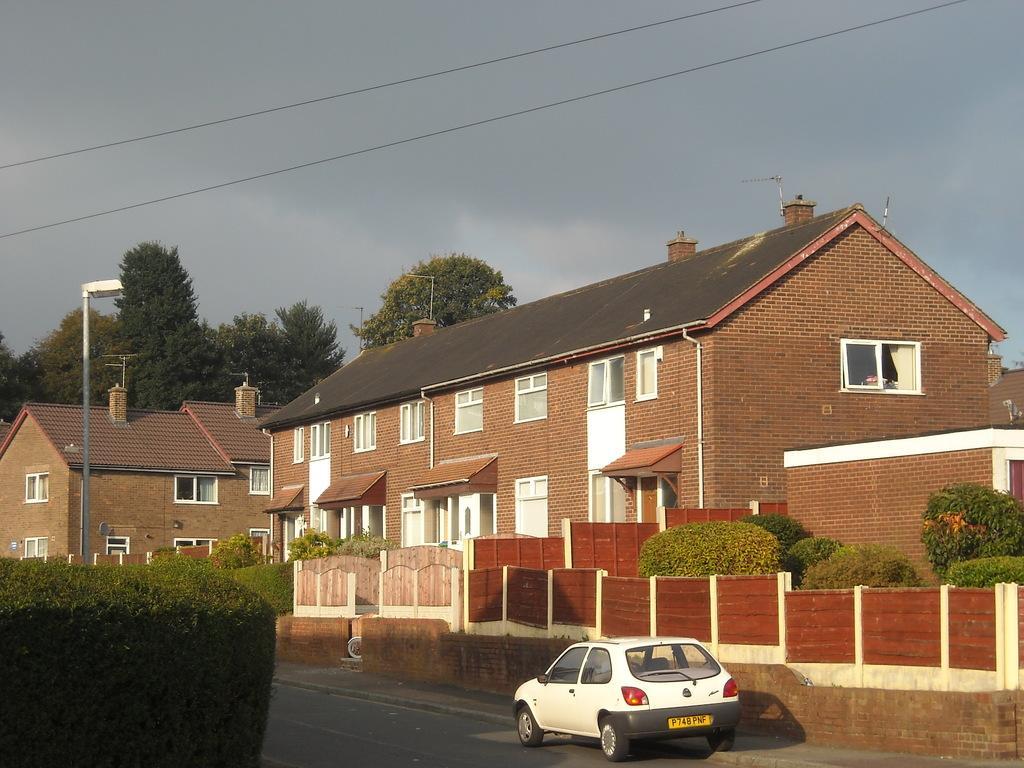Can you describe this image briefly? In the center of the image, we can see a car on the road and in the background, there are hedges and we can see a pole and there are buildings, trees and wires. At the top, there is sky. 